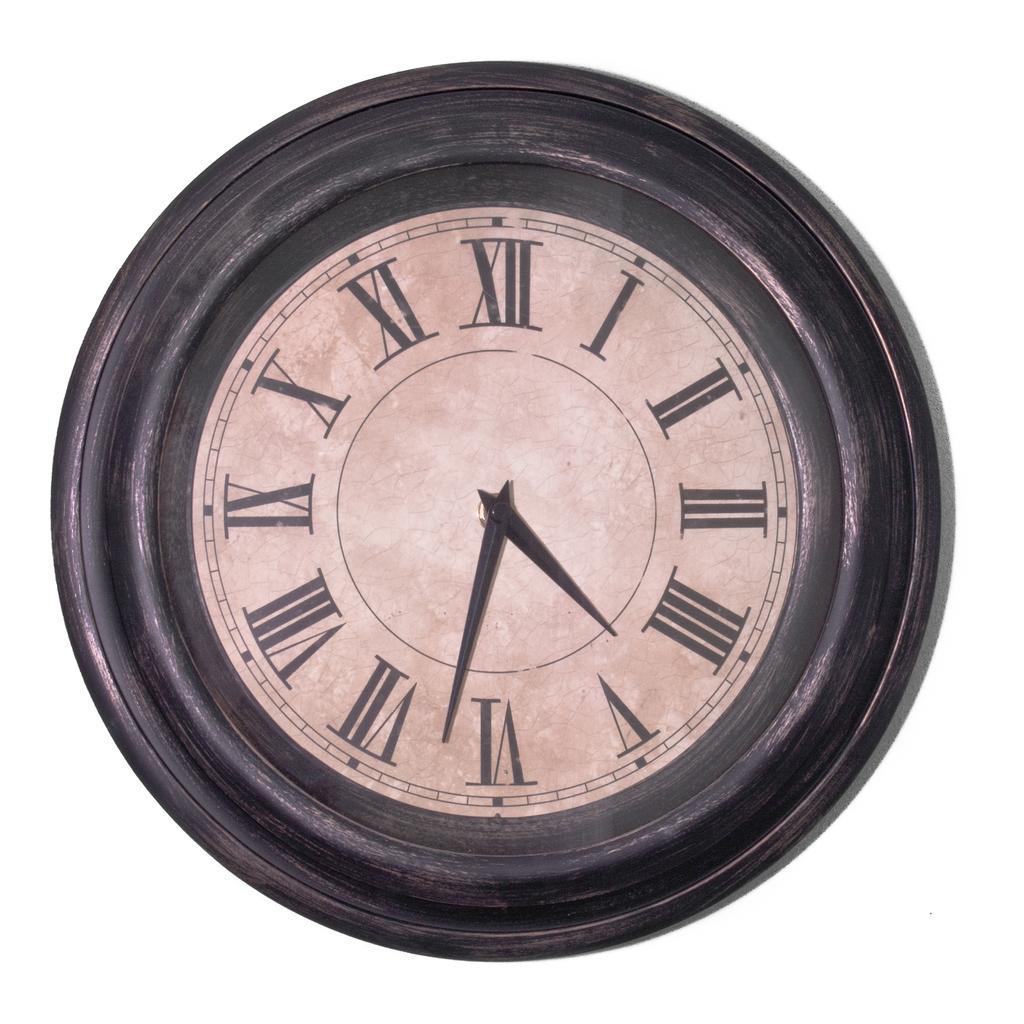What time is it?
Your answer should be very brief. 4:32. 